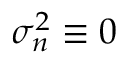<formula> <loc_0><loc_0><loc_500><loc_500>\sigma _ { n } ^ { 2 } \equiv 0</formula> 